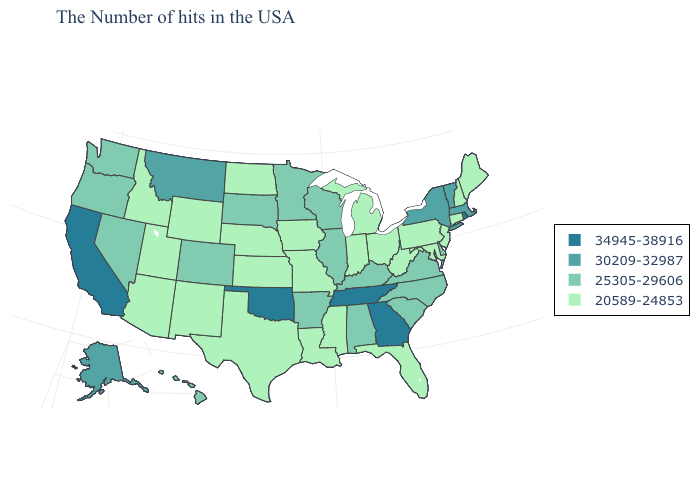What is the value of Alabama?
Give a very brief answer. 25305-29606. What is the value of Montana?
Concise answer only. 30209-32987. What is the highest value in the West ?
Write a very short answer. 34945-38916. Does New Jersey have the highest value in the USA?
Keep it brief. No. What is the value of Nevada?
Answer briefly. 25305-29606. Among the states that border Utah , which have the lowest value?
Keep it brief. Wyoming, New Mexico, Arizona, Idaho. What is the lowest value in the USA?
Quick response, please. 20589-24853. What is the value of Minnesota?
Keep it brief. 25305-29606. Name the states that have a value in the range 34945-38916?
Write a very short answer. Rhode Island, Georgia, Tennessee, Oklahoma, California. Which states have the lowest value in the USA?
Answer briefly. Maine, New Hampshire, Connecticut, New Jersey, Maryland, Pennsylvania, West Virginia, Ohio, Florida, Michigan, Indiana, Mississippi, Louisiana, Missouri, Iowa, Kansas, Nebraska, Texas, North Dakota, Wyoming, New Mexico, Utah, Arizona, Idaho. Does Kentucky have the lowest value in the South?
Write a very short answer. No. Which states have the highest value in the USA?
Give a very brief answer. Rhode Island, Georgia, Tennessee, Oklahoma, California. What is the value of Oklahoma?
Quick response, please. 34945-38916. Name the states that have a value in the range 25305-29606?
Keep it brief. Delaware, Virginia, North Carolina, South Carolina, Kentucky, Alabama, Wisconsin, Illinois, Arkansas, Minnesota, South Dakota, Colorado, Nevada, Washington, Oregon, Hawaii. What is the highest value in states that border Georgia?
Give a very brief answer. 34945-38916. 